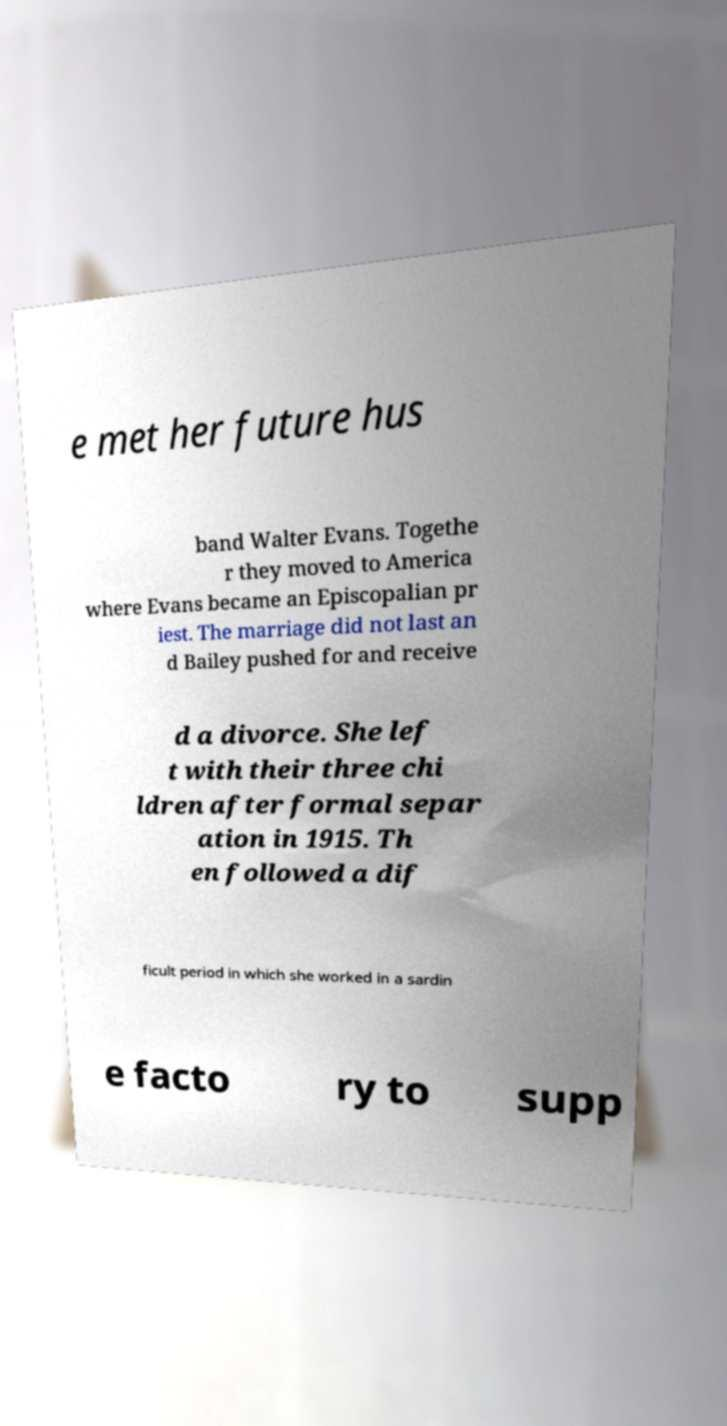What messages or text are displayed in this image? I need them in a readable, typed format. e met her future hus band Walter Evans. Togethe r they moved to America where Evans became an Episcopalian pr iest. The marriage did not last an d Bailey pushed for and receive d a divorce. She lef t with their three chi ldren after formal separ ation in 1915. Th en followed a dif ficult period in which she worked in a sardin e facto ry to supp 